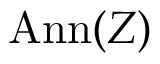<formula> <loc_0><loc_0><loc_500><loc_500>A n n ( Z )</formula> 